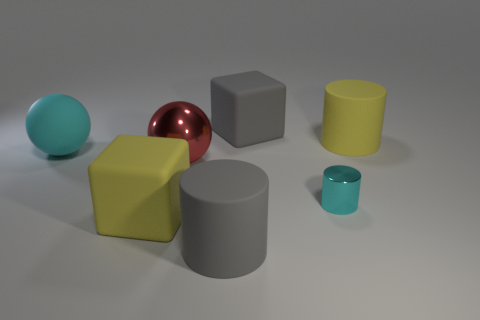Can you describe the colors and shapes of the objects in the image? Certainly! The image features a variety of geometric shapes, each with a distinct color. There's a cyan sphere, a red shiny sphere, a large gray cube, a yellow cube, a dark gray cylinder, a lime cylinder, and a small teal cup or cylindrical object. Each shape has a smooth texture, and they're evenly spaced on a neutral surface with a light source creating subtle shadows. 